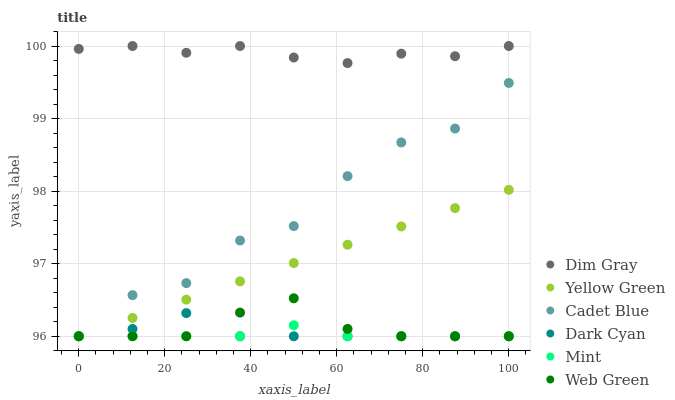Does Mint have the minimum area under the curve?
Answer yes or no. Yes. Does Dim Gray have the maximum area under the curve?
Answer yes or no. Yes. Does Yellow Green have the minimum area under the curve?
Answer yes or no. No. Does Yellow Green have the maximum area under the curve?
Answer yes or no. No. Is Yellow Green the smoothest?
Answer yes or no. Yes. Is Cadet Blue the roughest?
Answer yes or no. Yes. Is Web Green the smoothest?
Answer yes or no. No. Is Web Green the roughest?
Answer yes or no. No. Does Cadet Blue have the lowest value?
Answer yes or no. Yes. Does Dim Gray have the lowest value?
Answer yes or no. No. Does Dim Gray have the highest value?
Answer yes or no. Yes. Does Yellow Green have the highest value?
Answer yes or no. No. Is Cadet Blue less than Dim Gray?
Answer yes or no. Yes. Is Dim Gray greater than Cadet Blue?
Answer yes or no. Yes. Does Cadet Blue intersect Yellow Green?
Answer yes or no. Yes. Is Cadet Blue less than Yellow Green?
Answer yes or no. No. Is Cadet Blue greater than Yellow Green?
Answer yes or no. No. Does Cadet Blue intersect Dim Gray?
Answer yes or no. No. 